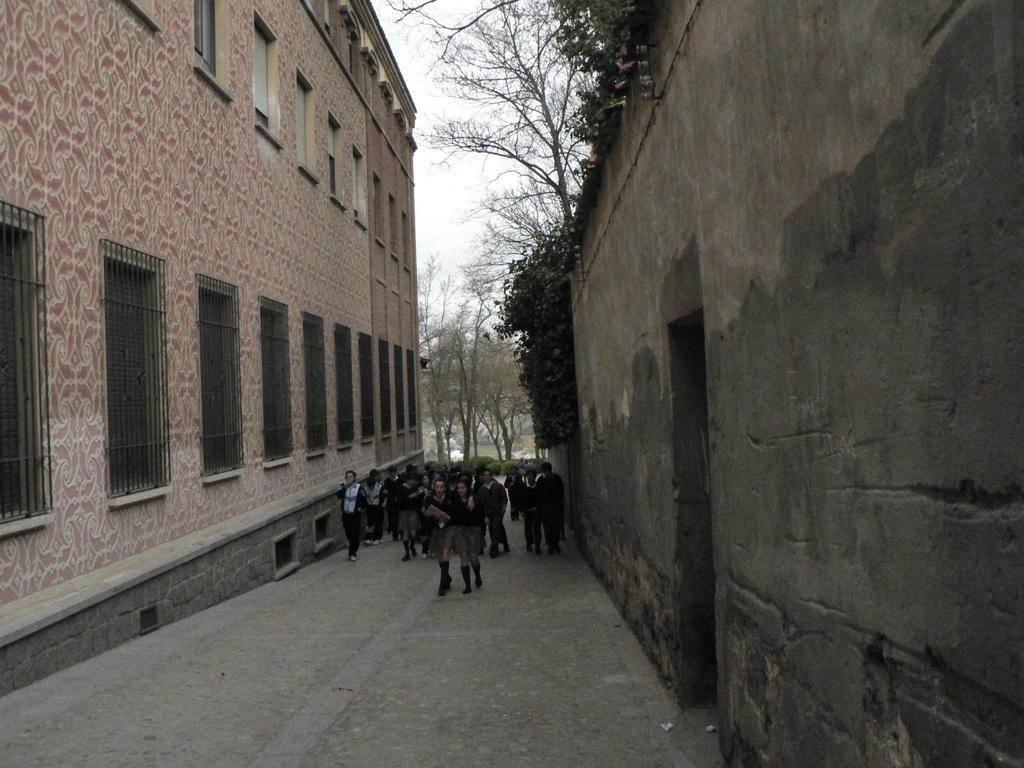Describe this image in one or two sentences. In this image there is a road, on that road childrens are walking, on either side of the road there are buildings, in the background there are trees. 